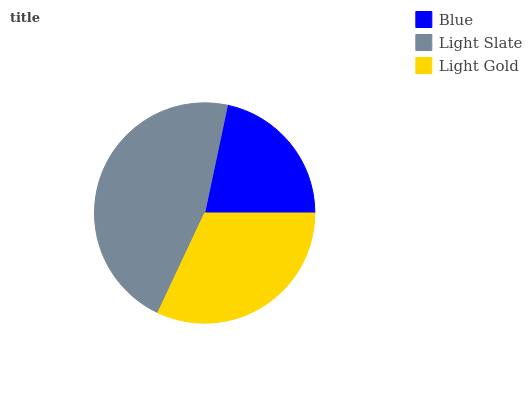Is Blue the minimum?
Answer yes or no. Yes. Is Light Slate the maximum?
Answer yes or no. Yes. Is Light Gold the minimum?
Answer yes or no. No. Is Light Gold the maximum?
Answer yes or no. No. Is Light Slate greater than Light Gold?
Answer yes or no. Yes. Is Light Gold less than Light Slate?
Answer yes or no. Yes. Is Light Gold greater than Light Slate?
Answer yes or no. No. Is Light Slate less than Light Gold?
Answer yes or no. No. Is Light Gold the high median?
Answer yes or no. Yes. Is Light Gold the low median?
Answer yes or no. Yes. Is Blue the high median?
Answer yes or no. No. Is Blue the low median?
Answer yes or no. No. 